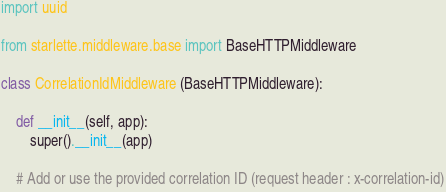<code> <loc_0><loc_0><loc_500><loc_500><_Python_>import uuid

from starlette.middleware.base import BaseHTTPMiddleware

class CorrelationIdMiddleware (BaseHTTPMiddleware):

    def __init__(self, app):
        super().__init__(app)

    # Add or use the provided correlation ID (request header : x-correlation-id)</code> 